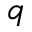<formula> <loc_0><loc_0><loc_500><loc_500>q</formula> 